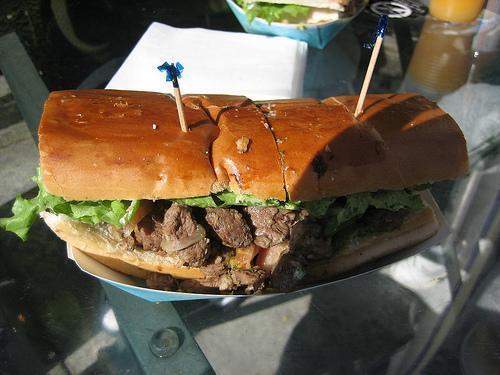How many paper food containers do you see?
Give a very brief answer. 2. How many toothpicks do you see?
Give a very brief answer. 2. 